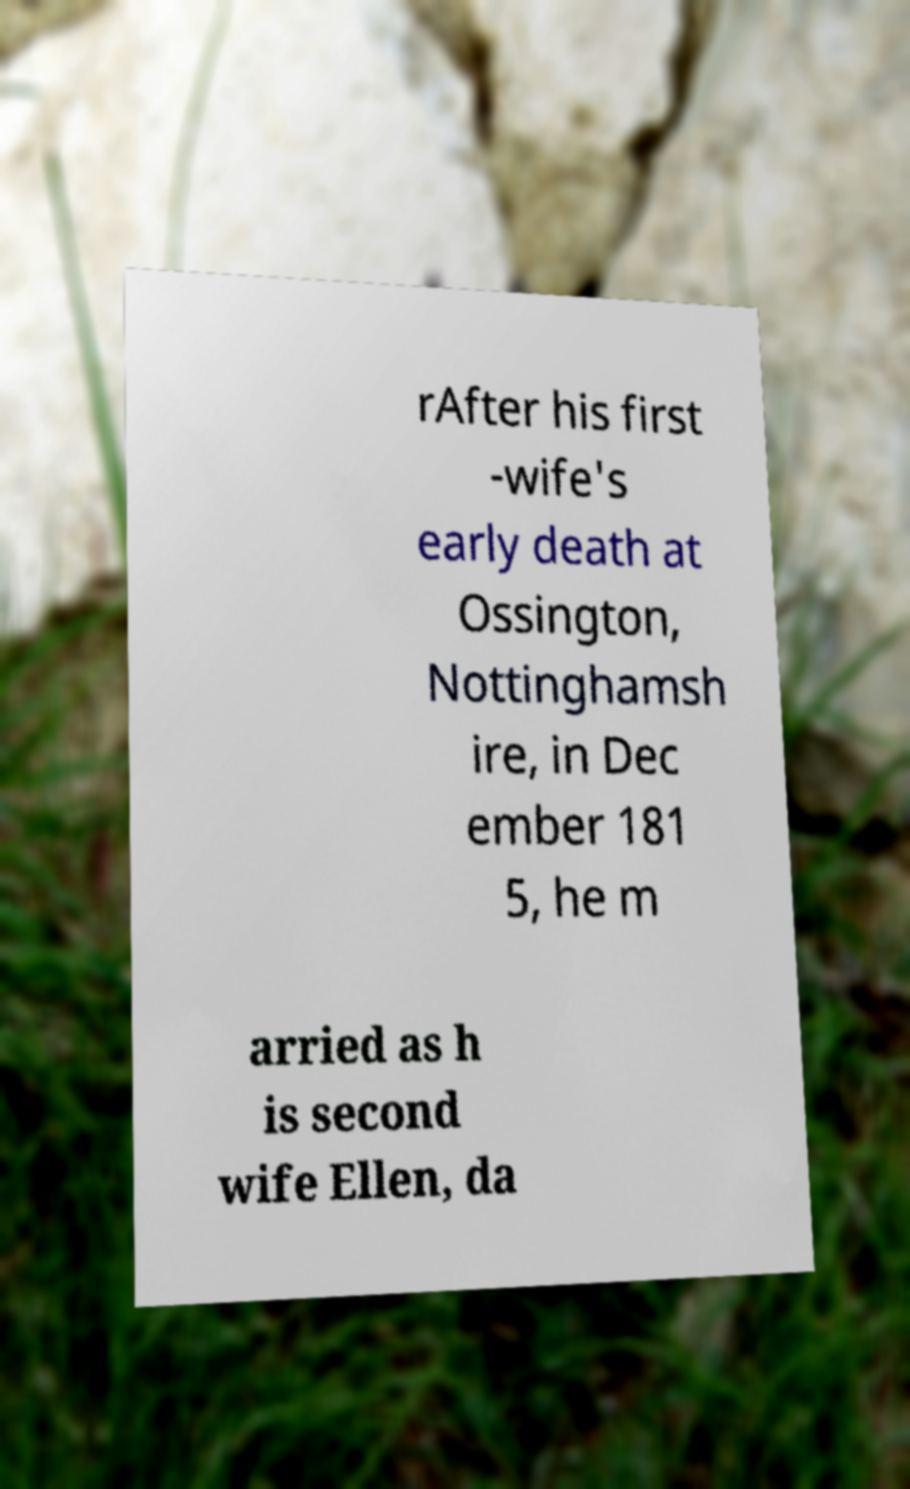Please identify and transcribe the text found in this image. rAfter his first -wife's early death at Ossington, Nottinghamsh ire, in Dec ember 181 5, he m arried as h is second wife Ellen, da 